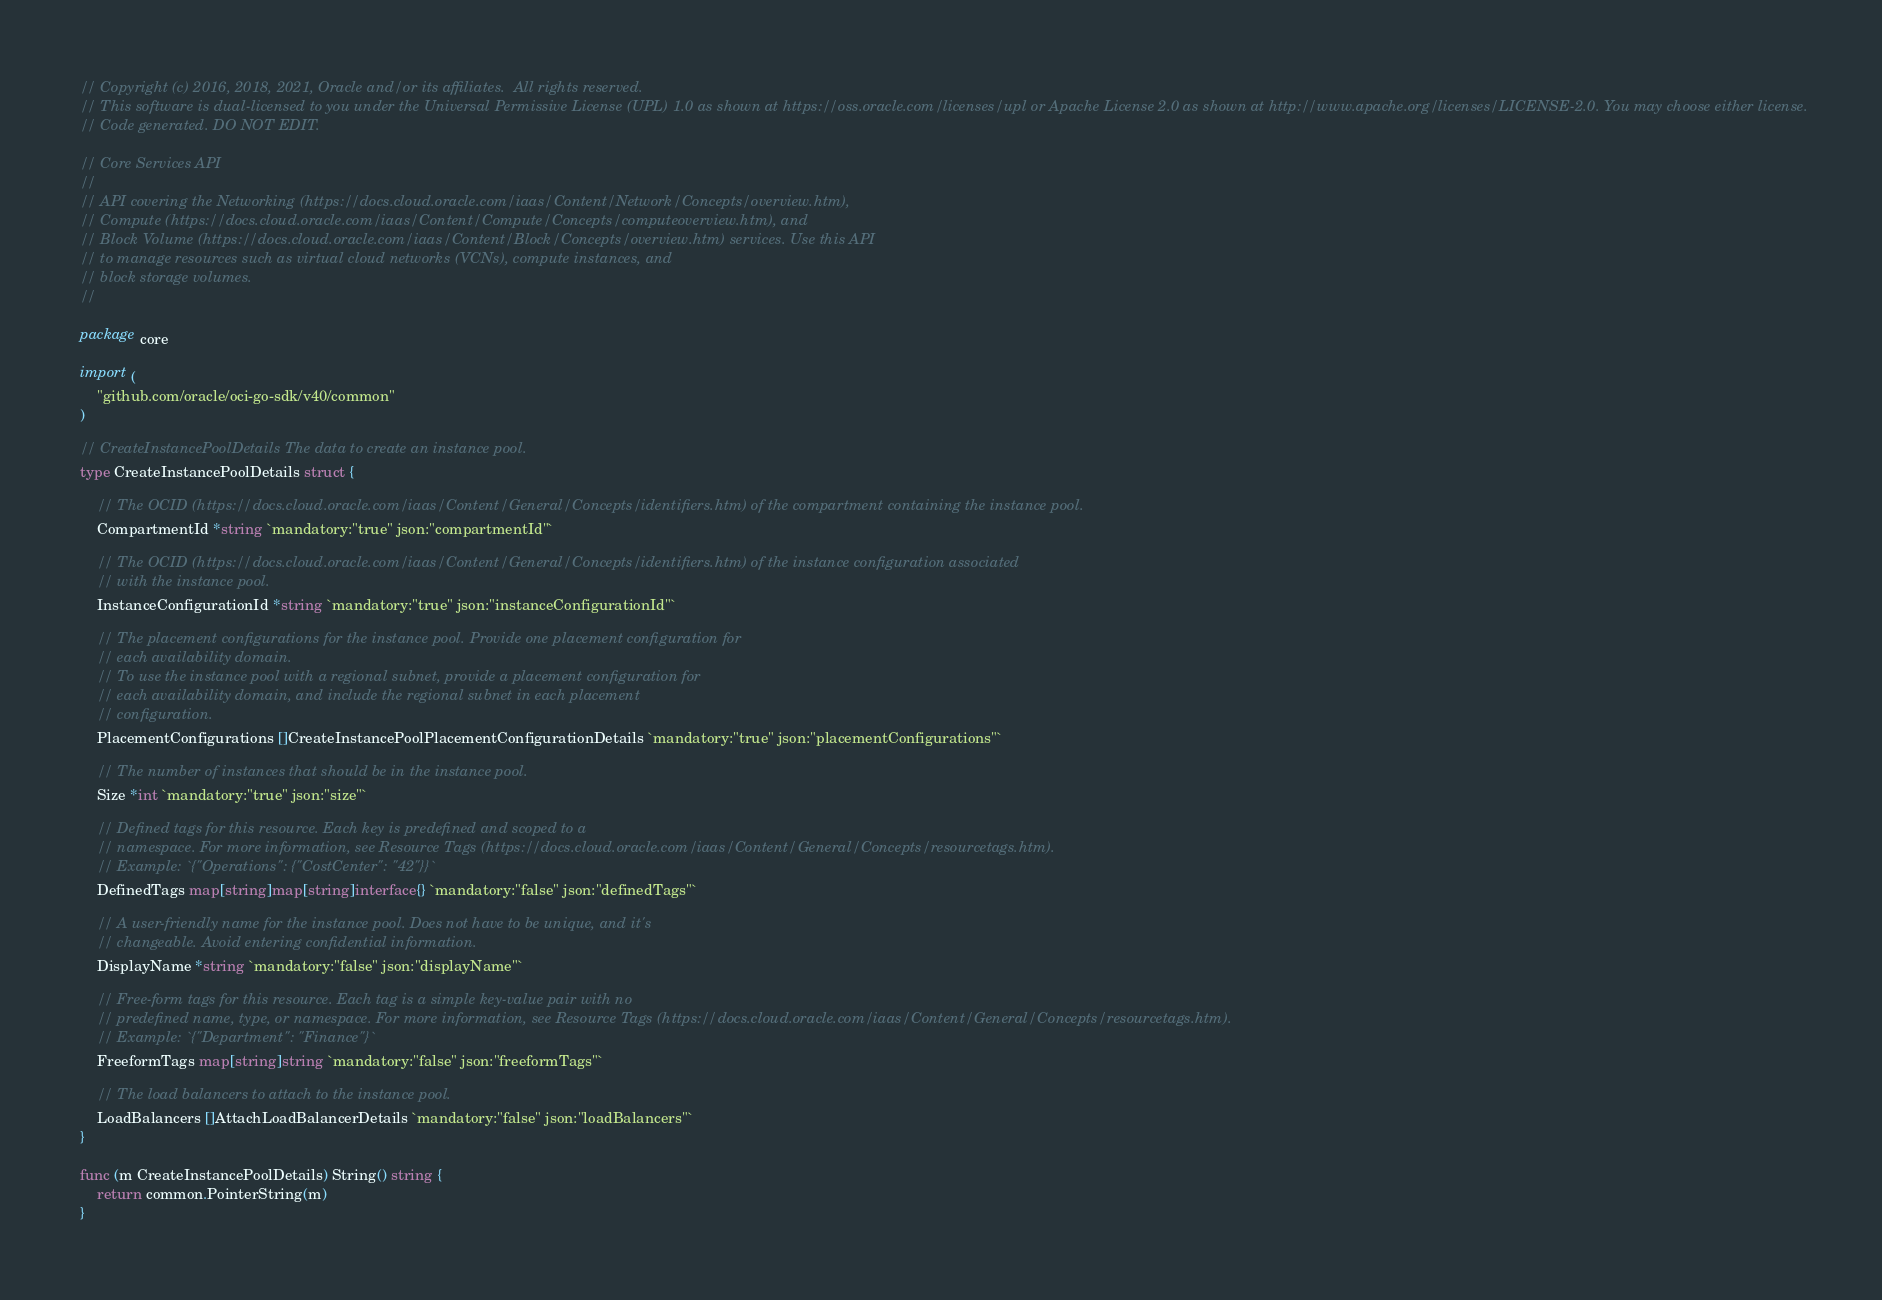Convert code to text. <code><loc_0><loc_0><loc_500><loc_500><_Go_>// Copyright (c) 2016, 2018, 2021, Oracle and/or its affiliates.  All rights reserved.
// This software is dual-licensed to you under the Universal Permissive License (UPL) 1.0 as shown at https://oss.oracle.com/licenses/upl or Apache License 2.0 as shown at http://www.apache.org/licenses/LICENSE-2.0. You may choose either license.
// Code generated. DO NOT EDIT.

// Core Services API
//
// API covering the Networking (https://docs.cloud.oracle.com/iaas/Content/Network/Concepts/overview.htm),
// Compute (https://docs.cloud.oracle.com/iaas/Content/Compute/Concepts/computeoverview.htm), and
// Block Volume (https://docs.cloud.oracle.com/iaas/Content/Block/Concepts/overview.htm) services. Use this API
// to manage resources such as virtual cloud networks (VCNs), compute instances, and
// block storage volumes.
//

package core

import (
	"github.com/oracle/oci-go-sdk/v40/common"
)

// CreateInstancePoolDetails The data to create an instance pool.
type CreateInstancePoolDetails struct {

	// The OCID (https://docs.cloud.oracle.com/iaas/Content/General/Concepts/identifiers.htm) of the compartment containing the instance pool.
	CompartmentId *string `mandatory:"true" json:"compartmentId"`

	// The OCID (https://docs.cloud.oracle.com/iaas/Content/General/Concepts/identifiers.htm) of the instance configuration associated
	// with the instance pool.
	InstanceConfigurationId *string `mandatory:"true" json:"instanceConfigurationId"`

	// The placement configurations for the instance pool. Provide one placement configuration for
	// each availability domain.
	// To use the instance pool with a regional subnet, provide a placement configuration for
	// each availability domain, and include the regional subnet in each placement
	// configuration.
	PlacementConfigurations []CreateInstancePoolPlacementConfigurationDetails `mandatory:"true" json:"placementConfigurations"`

	// The number of instances that should be in the instance pool.
	Size *int `mandatory:"true" json:"size"`

	// Defined tags for this resource. Each key is predefined and scoped to a
	// namespace. For more information, see Resource Tags (https://docs.cloud.oracle.com/iaas/Content/General/Concepts/resourcetags.htm).
	// Example: `{"Operations": {"CostCenter": "42"}}`
	DefinedTags map[string]map[string]interface{} `mandatory:"false" json:"definedTags"`

	// A user-friendly name for the instance pool. Does not have to be unique, and it's
	// changeable. Avoid entering confidential information.
	DisplayName *string `mandatory:"false" json:"displayName"`

	// Free-form tags for this resource. Each tag is a simple key-value pair with no
	// predefined name, type, or namespace. For more information, see Resource Tags (https://docs.cloud.oracle.com/iaas/Content/General/Concepts/resourcetags.htm).
	// Example: `{"Department": "Finance"}`
	FreeformTags map[string]string `mandatory:"false" json:"freeformTags"`

	// The load balancers to attach to the instance pool.
	LoadBalancers []AttachLoadBalancerDetails `mandatory:"false" json:"loadBalancers"`
}

func (m CreateInstancePoolDetails) String() string {
	return common.PointerString(m)
}
</code> 